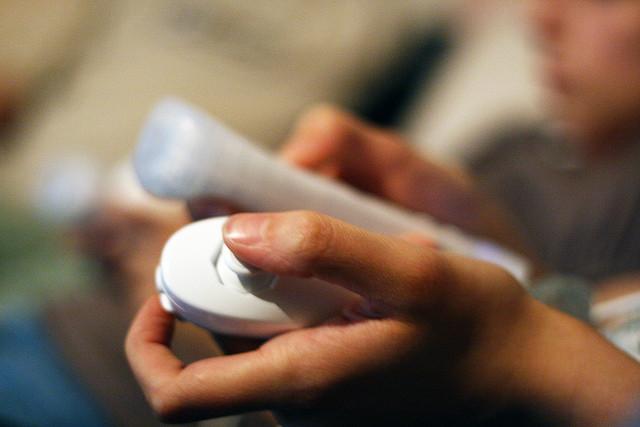What is this person doing?
Be succinct. Playing wii. Is the joystick in the left or right hand?
Be succinct. Left. Is the hand in the forefront clean?
Write a very short answer. Yes. 